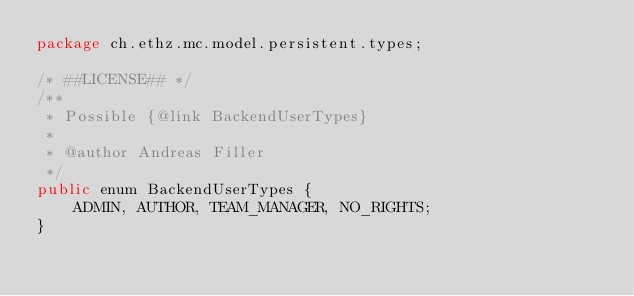<code> <loc_0><loc_0><loc_500><loc_500><_Java_>package ch.ethz.mc.model.persistent.types;

/* ##LICENSE## */
/**
 * Possible {@link BackendUserTypes}
 *
 * @author Andreas Filler
 */
public enum BackendUserTypes {
	ADMIN, AUTHOR, TEAM_MANAGER, NO_RIGHTS;
}
</code> 